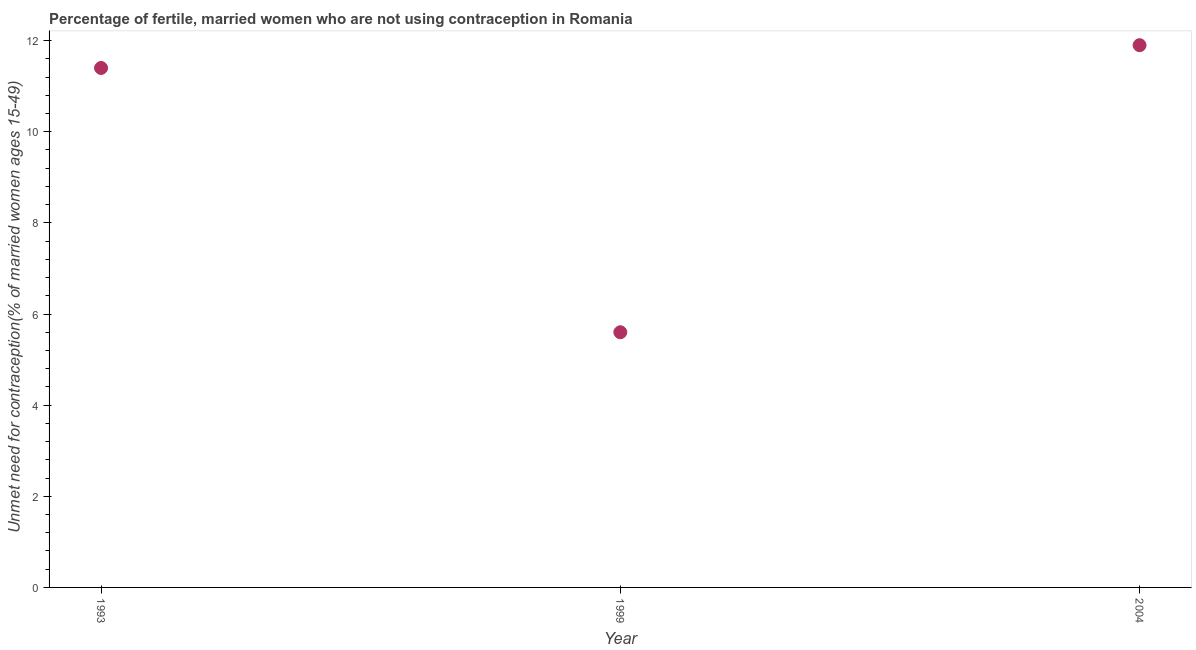What is the number of married women who are not using contraception in 1999?
Offer a terse response. 5.6. Across all years, what is the minimum number of married women who are not using contraception?
Ensure brevity in your answer.  5.6. In which year was the number of married women who are not using contraception maximum?
Ensure brevity in your answer.  2004. What is the sum of the number of married women who are not using contraception?
Your response must be concise. 28.9. What is the difference between the number of married women who are not using contraception in 1999 and 2004?
Your answer should be very brief. -6.3. What is the average number of married women who are not using contraception per year?
Offer a terse response. 9.63. Do a majority of the years between 1999 and 2004 (inclusive) have number of married women who are not using contraception greater than 8.8 %?
Ensure brevity in your answer.  No. What is the ratio of the number of married women who are not using contraception in 1993 to that in 2004?
Make the answer very short. 0.96. Is the number of married women who are not using contraception in 1993 less than that in 2004?
Your answer should be compact. Yes. Is the difference between the number of married women who are not using contraception in 1999 and 2004 greater than the difference between any two years?
Your answer should be compact. Yes. What is the difference between the highest and the second highest number of married women who are not using contraception?
Your response must be concise. 0.5. Is the sum of the number of married women who are not using contraception in 1999 and 2004 greater than the maximum number of married women who are not using contraception across all years?
Offer a very short reply. Yes. What is the difference between the highest and the lowest number of married women who are not using contraception?
Your answer should be compact. 6.3. Does the number of married women who are not using contraception monotonically increase over the years?
Ensure brevity in your answer.  No. How many dotlines are there?
Provide a succinct answer. 1. Does the graph contain any zero values?
Give a very brief answer. No. What is the title of the graph?
Make the answer very short. Percentage of fertile, married women who are not using contraception in Romania. What is the label or title of the Y-axis?
Offer a very short reply.  Unmet need for contraception(% of married women ages 15-49). What is the difference between the  Unmet need for contraception(% of married women ages 15-49) in 1993 and 2004?
Offer a very short reply. -0.5. What is the difference between the  Unmet need for contraception(% of married women ages 15-49) in 1999 and 2004?
Make the answer very short. -6.3. What is the ratio of the  Unmet need for contraception(% of married women ages 15-49) in 1993 to that in 1999?
Make the answer very short. 2.04. What is the ratio of the  Unmet need for contraception(% of married women ages 15-49) in 1993 to that in 2004?
Offer a very short reply. 0.96. What is the ratio of the  Unmet need for contraception(% of married women ages 15-49) in 1999 to that in 2004?
Provide a succinct answer. 0.47. 